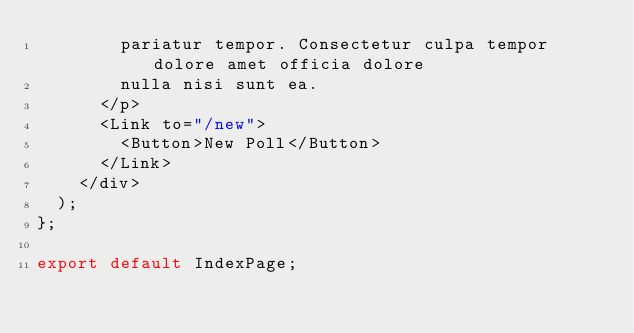Convert code to text. <code><loc_0><loc_0><loc_500><loc_500><_JavaScript_>        pariatur tempor. Consectetur culpa tempor dolore amet officia dolore
        nulla nisi sunt ea.
      </p>
      <Link to="/new">
        <Button>New Poll</Button>
      </Link>
    </div>
  );
};

export default IndexPage;
</code> 